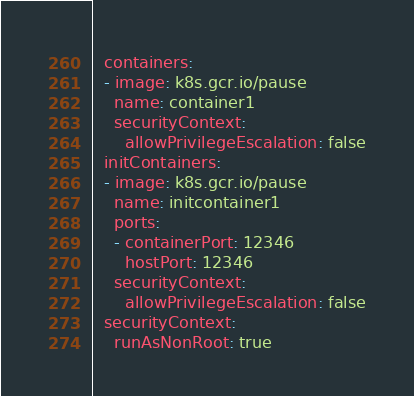<code> <loc_0><loc_0><loc_500><loc_500><_YAML_>  containers:
  - image: k8s.gcr.io/pause
    name: container1
    securityContext:
      allowPrivilegeEscalation: false
  initContainers:
  - image: k8s.gcr.io/pause
    name: initcontainer1
    ports:
    - containerPort: 12346
      hostPort: 12346
    securityContext:
      allowPrivilegeEscalation: false
  securityContext:
    runAsNonRoot: true
</code> 